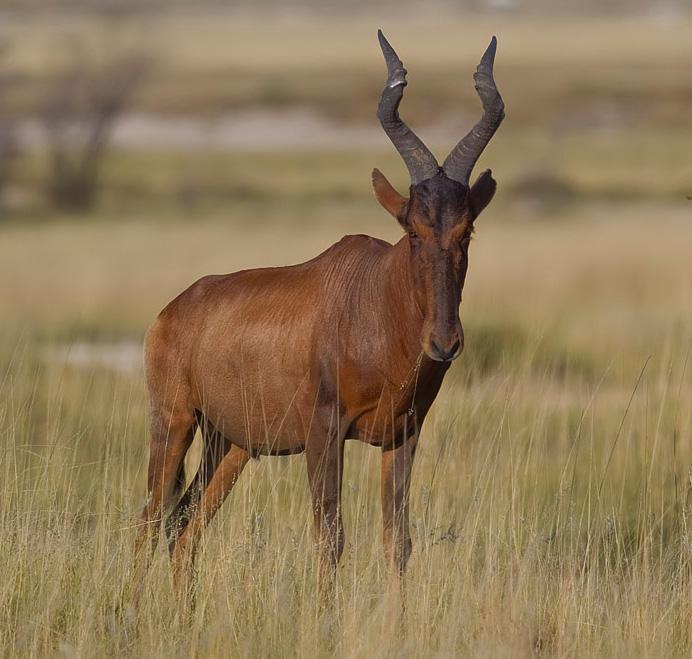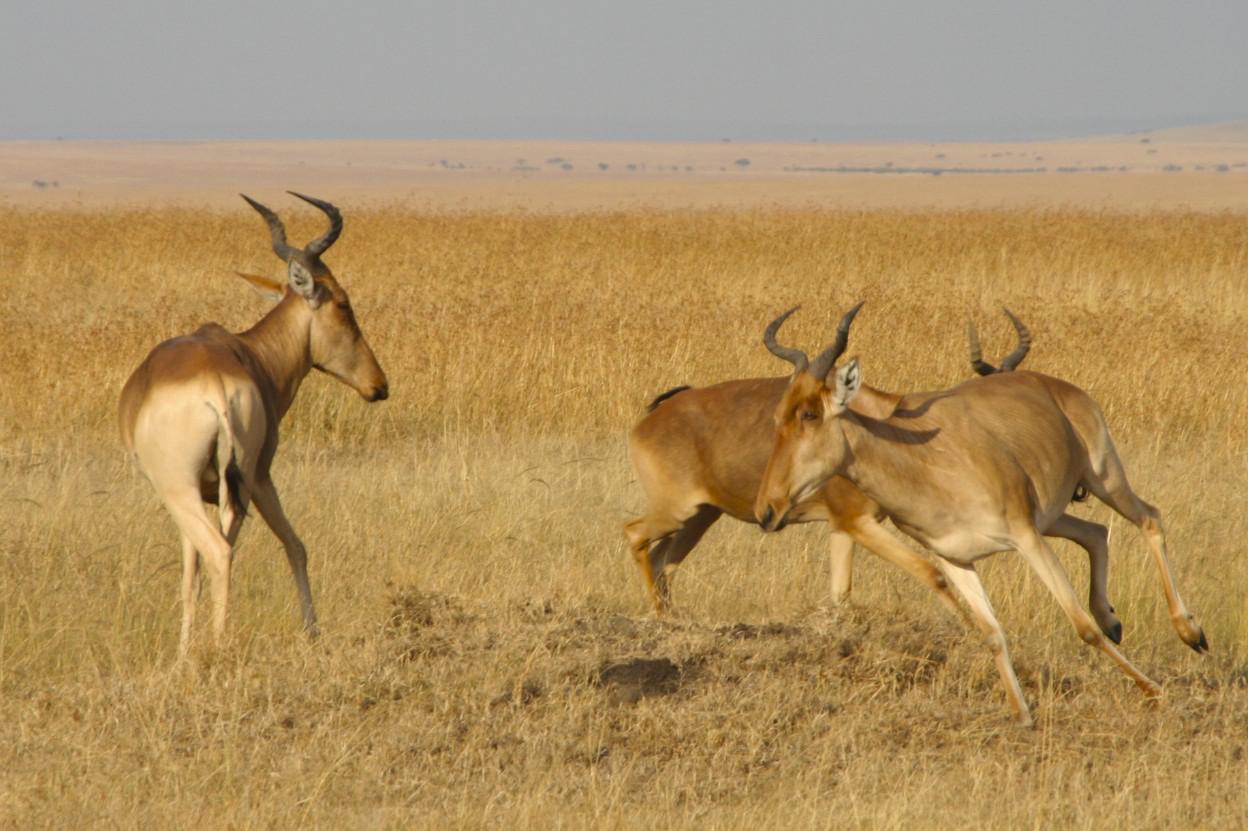The first image is the image on the left, the second image is the image on the right. Examine the images to the left and right. Is the description "A single horned animal is standing in the grass in the image on the left." accurate? Answer yes or no. Yes. 